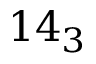<formula> <loc_0><loc_0><loc_500><loc_500>1 4 _ { 3 }</formula> 